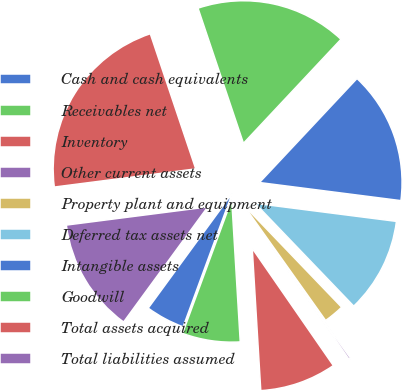Convert chart. <chart><loc_0><loc_0><loc_500><loc_500><pie_chart><fcel>Cash and cash equivalents<fcel>Receivables net<fcel>Inventory<fcel>Other current assets<fcel>Property plant and equipment<fcel>Deferred tax assets net<fcel>Intangible assets<fcel>Goodwill<fcel>Total assets acquired<fcel>Total liabilities assumed<nl><fcel>4.44%<fcel>6.56%<fcel>8.68%<fcel>0.21%<fcel>2.33%<fcel>10.8%<fcel>15.04%<fcel>17.15%<fcel>21.87%<fcel>12.92%<nl></chart> 